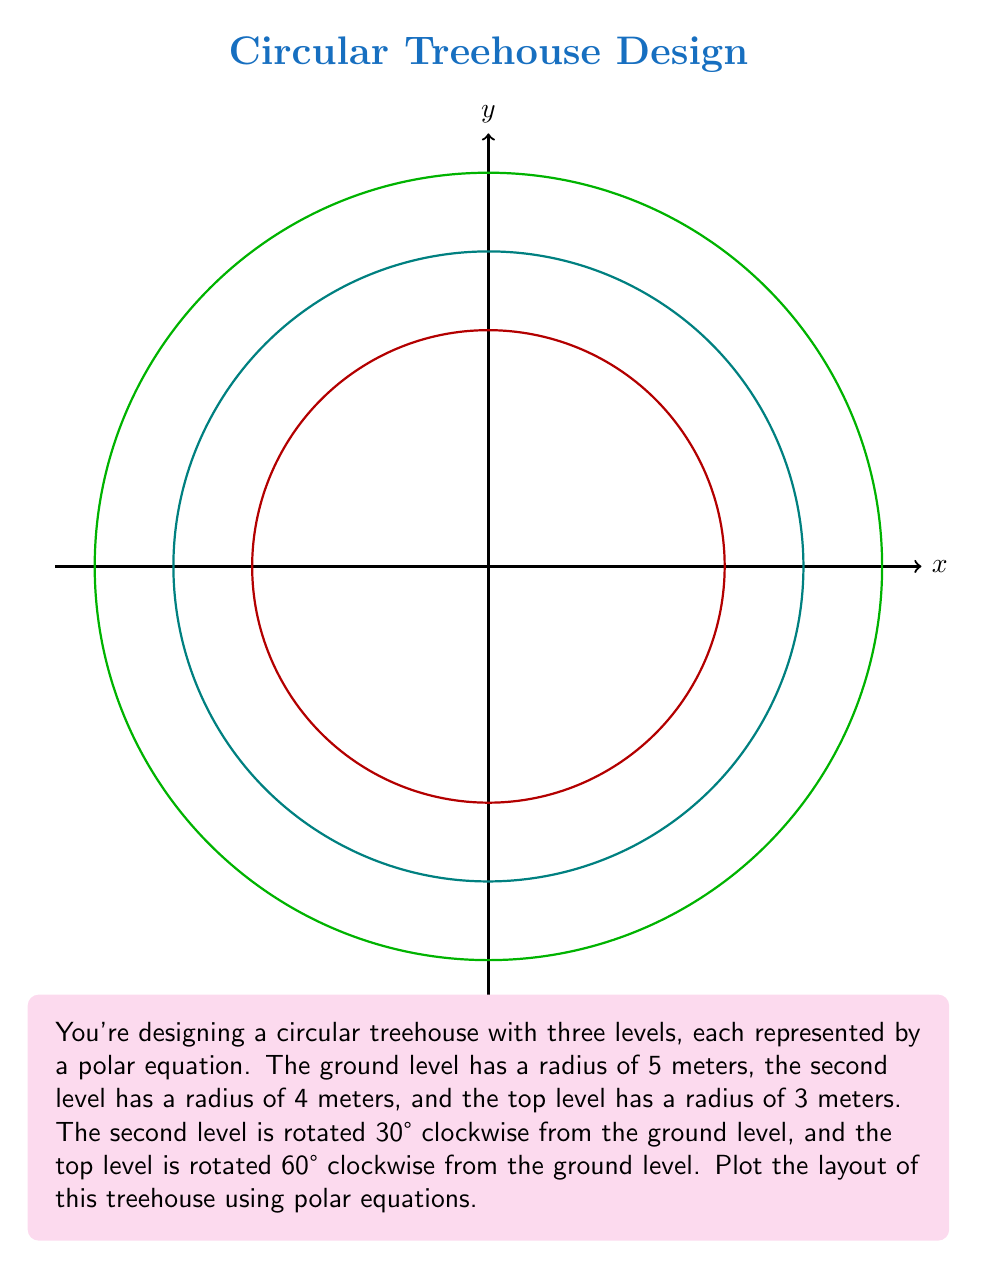Could you help me with this problem? To plot the layout of the circular treehouse, we need to create polar equations for each level:

1. Ground level (green):
   The equation is simply $r = 5$, as it's a circle centered at the origin with a radius of 5 meters.

2. Second level (cyan):
   This level is rotated 30° clockwise, which is equivalent to -30° or -π/6 radians. The equation is:
   $r = 4$ when $\theta \geq -\frac{\pi}{6}$

3. Top level (red):
   This level is rotated 60° clockwise, which is equivalent to -60° or -π/3 radians. The equation is:
   $r = 3$ when $\theta \geq -\frac{\pi}{3}$

To plot these equations:

1. Draw a circle with radius 5 centered at the origin for the ground level.
2. Draw a circle with radius 4 centered at the origin, but only show the part where $\theta \geq -\frac{\pi}{6}$.
3. Draw a circle with radius 3 centered at the origin, but only show the part where $\theta \geq -\frac{\pi}{3}$.

The resulting plot will show the three levels of the treehouse, with each upper level slightly smaller and rotated clockwise from the one below it.
Answer: $$r = \begin{cases}
5, & \text{for all } \theta \\
4, & \text{for } \theta \geq -\frac{\pi}{6} \\
3, & \text{for } \theta \geq -\frac{\pi}{3}
\end{cases}$$ 